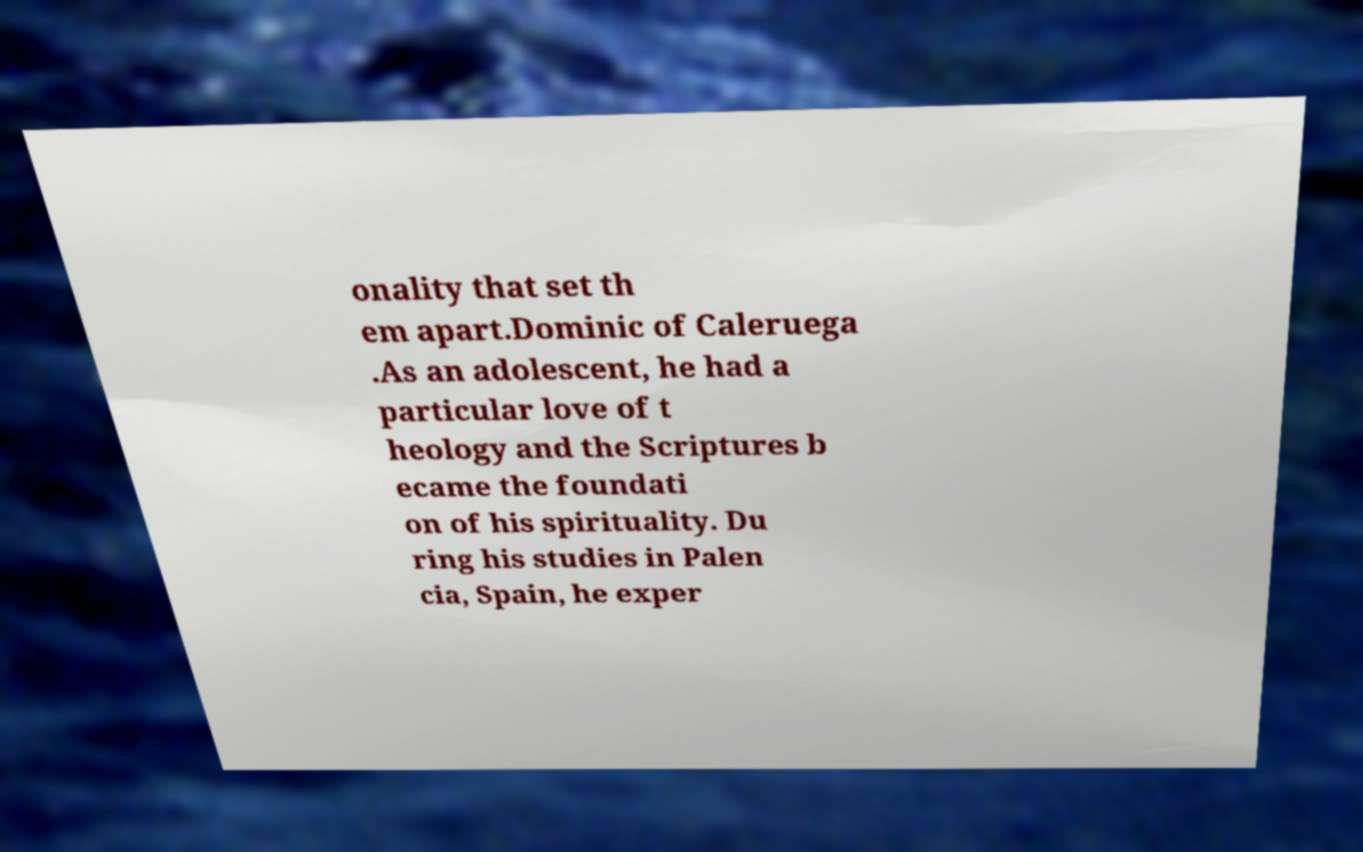Could you extract and type out the text from this image? onality that set th em apart.Dominic of Caleruega .As an adolescent, he had a particular love of t heology and the Scriptures b ecame the foundati on of his spirituality. Du ring his studies in Palen cia, Spain, he exper 